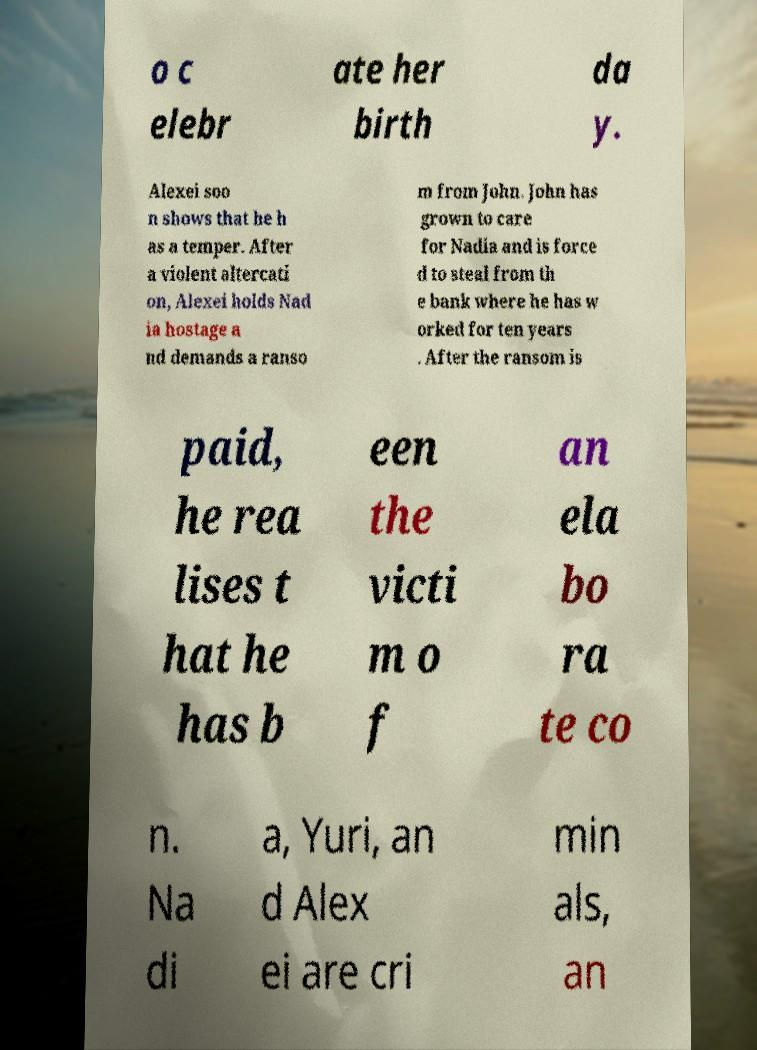Please read and relay the text visible in this image. What does it say? o c elebr ate her birth da y. Alexei soo n shows that he h as a temper. After a violent altercati on, Alexei holds Nad ia hostage a nd demands a ranso m from John. John has grown to care for Nadia and is force d to steal from th e bank where he has w orked for ten years . After the ransom is paid, he rea lises t hat he has b een the victi m o f an ela bo ra te co n. Na di a, Yuri, an d Alex ei are cri min als, an 